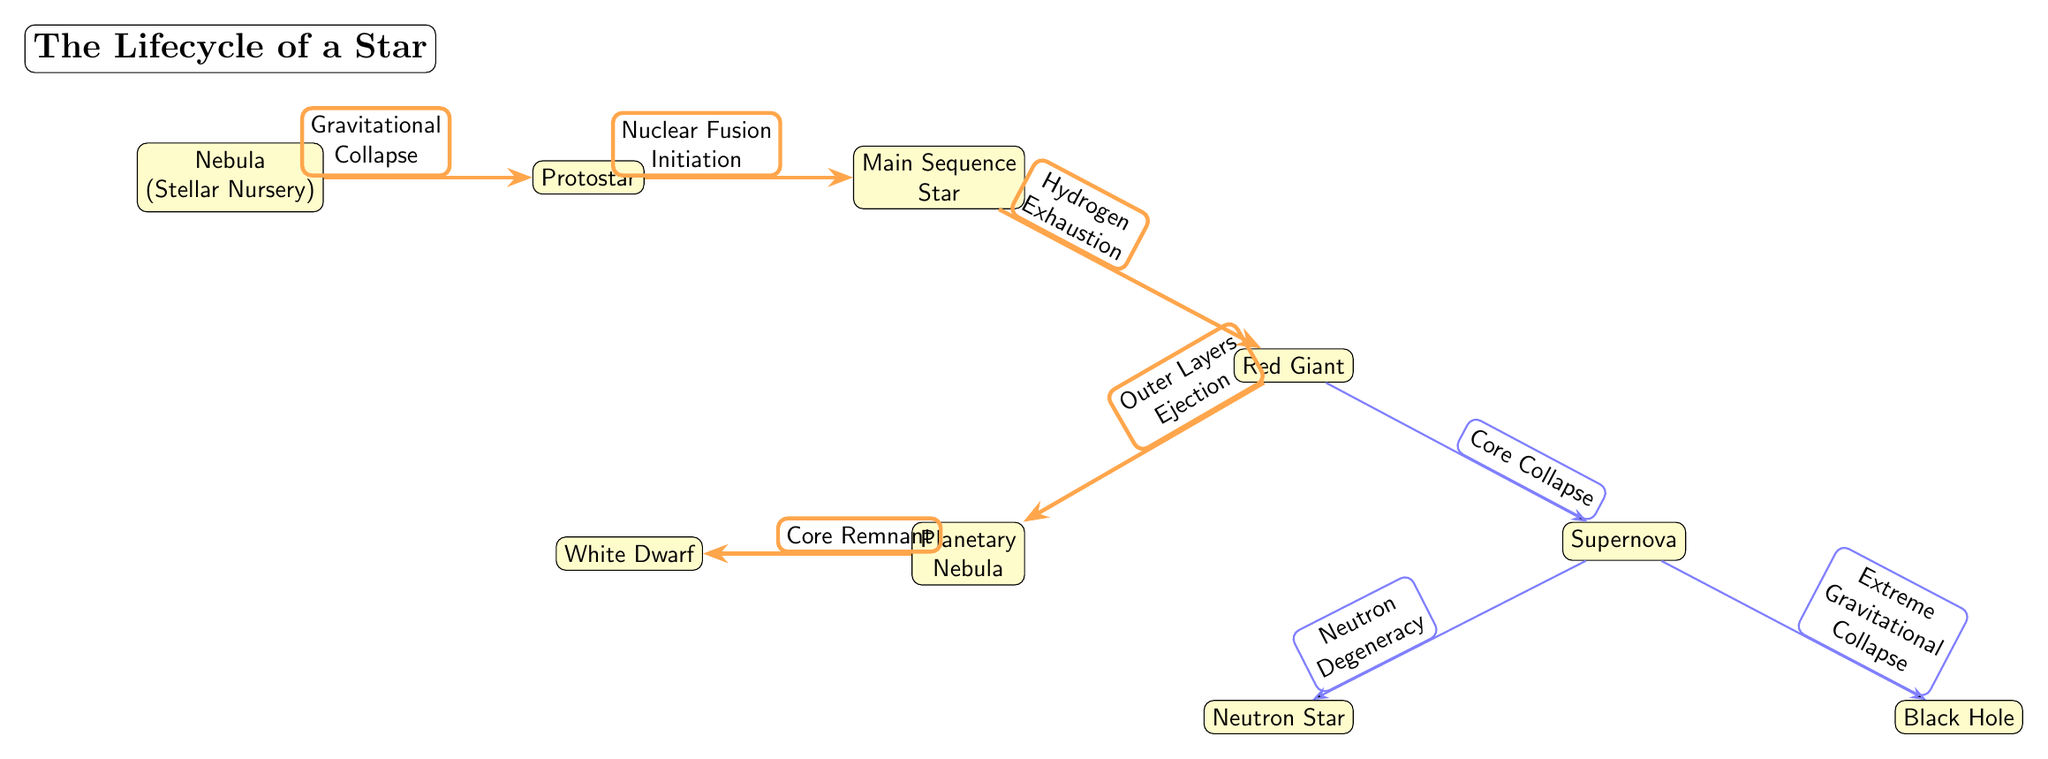What is the first stage of a star's lifecycle? The diagram shows that the first stage is a "Nebula", depicted as the leftmost node labeled "Nebula (Stellar Nursery)"
Answer: Nebula Which process initiates the transition from a protostar to a main sequence star? The diagram indicates that the transition is marked by "Nuclear Fusion Initiation", which is the label on the arrow connecting the protostar to the main sequence star
Answer: Nuclear Fusion Initiation How many end states are there after the supernova stage? By observing the diagram, we can count that there are two end states branching from the supernova: "Neutron Star" and "Black Hole"
Answer: 2 What does the red giant stage lead to? The diagram shows that the red giant stage leads to two different outcomes: one being "Planetary Nebula" and the other being a transition to "Supernova". Since "Planetary Nebula" comes directly from the red giant, it is the immediate next stage
Answer: Planetary Nebula What phase follows the "Main Sequence Star"? You can follow the flow of the diagram from the "Main Sequence Star" node, which has an arrow pointing toward the "Red Giant". Thus, the phase that follows is clearly depicted as "Red Giant"
Answer: Red Giant What causes the ejection of outer layers in a star's lifecycle? The diagram states that the process labeled on the connection from "Red Giant" to "Planetary Nebula" is "Outer Layers Ejection", which directly explains the cause
Answer: Outer Layers Ejection What is the core remnant after the planetary nebula's formation? According to the diagram, after the "Planetary Nebula" stage, the next phase is labeled as "White Dwarf", which signifies that this is the core remnant left behind
Answer: White Dwarf What is the relationship between "Neutron Star" and "Supernova"? The diagram shows a direct transition labeled "Neutron Degeneracy" from "Supernova" to "Neutron Star", illustrating that the supernova can lead to the formation of a neutron star
Answer: Neutron Degeneracy What happens when a red giant undergoes core collapse? The transition from the "Red Giant" to "Supernova" is marked as "Core Collapse" in the diagram, indicating that core collapse is what triggers the supernova event
Answer: Core Collapse 